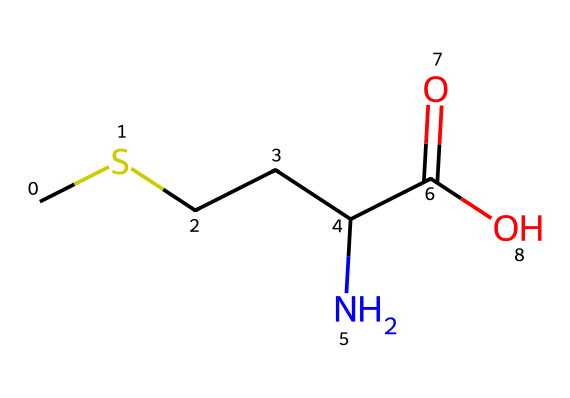What is the molecular formula of methionine? The SMILES representation indicates the presence of the carbon (C), hydrogen (H), nitrogen (N), oxygen (O), and sulfur (S) atoms with respective counts. Counting these from the structure gives us C5H11NO2S.
Answer: C5H11NO2S How many carbon atoms are in methionine? By examining the SMILES string, we can identify that the letter "C" appears five times, indicating there are five carbon atoms in the structure.
Answer: 5 What functional groups are present in methionine? The structure includes a carboxyl group (COOH) denoted by the "C(=O)O" and an amino group (NH2) represented by "N". Thus, the functional groups are identified as a carboxylic acid and an amine.
Answer: carboxylic acid and amine What type of amino acid is methionine? Methionine contains a sulfur atom in its side chain (the "S" in the SMILES), classifying it as a sulfur-containing amino acid, essential for protein synthesis.
Answer: sulfur-containing How many nitrogen atoms are present in methionine? Observing the SMILES, there is one letter "N", which indicates the presence of one nitrogen atom in the structure of methionine.
Answer: 1 Which atom in methionine is responsible for its organosulfur compound classification? The presence of the sulfur atom (the letter "S" in the SMILES) categorizes methionine as an organosulfur compound since it contains sulfur in its structure.
Answer: sulfur When considering the molecular structure, what is the total number of bonds in methionine? By analyzing the connectivity in the SMILES, we can deduce that there are twelve bonds present, which consists of single and double bonds counted across the atoms (C, H, O, N, and S).
Answer: 12 